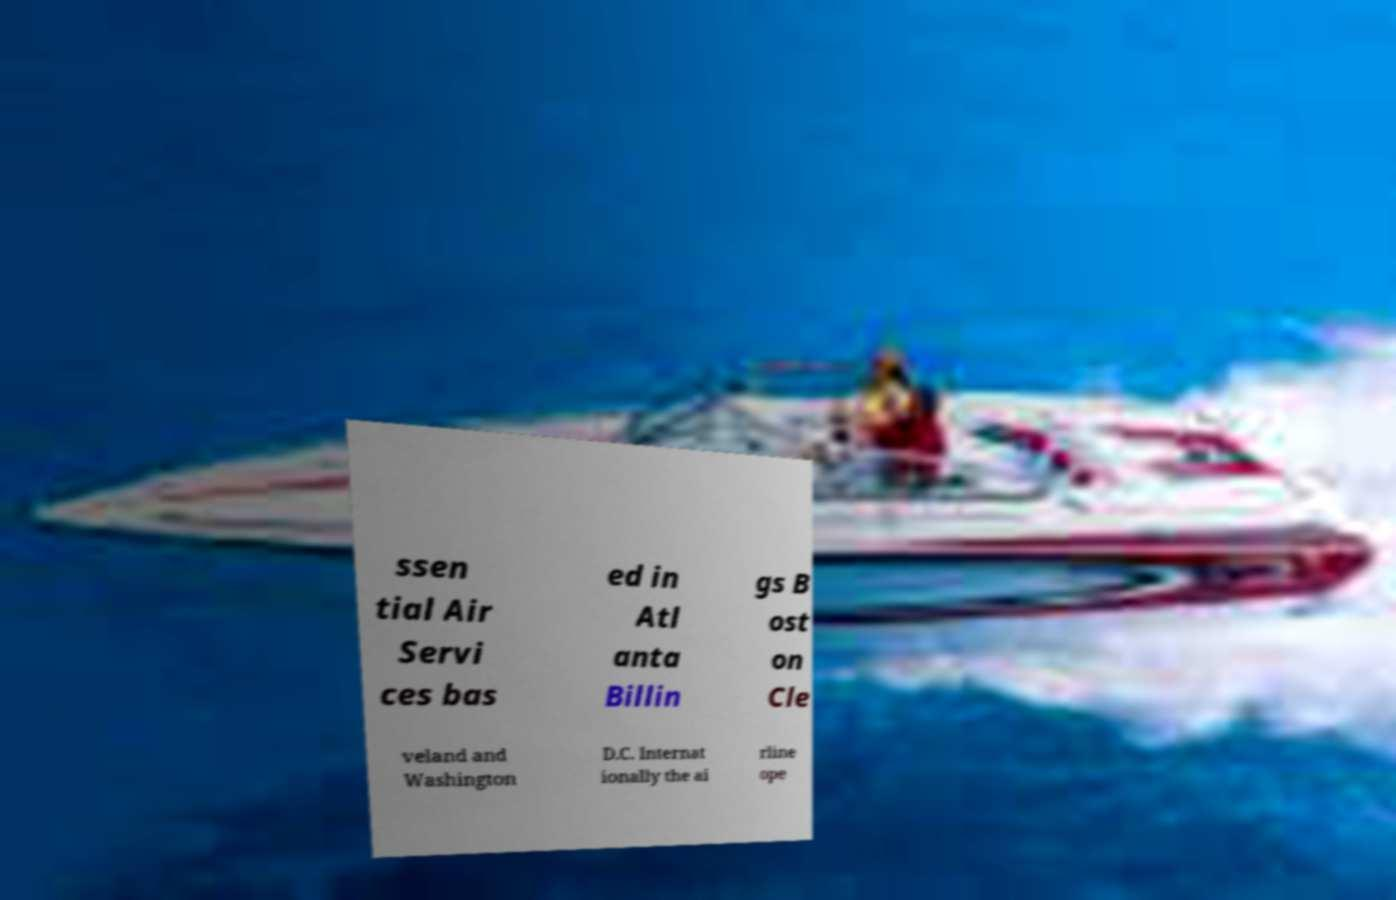Can you accurately transcribe the text from the provided image for me? ssen tial Air Servi ces bas ed in Atl anta Billin gs B ost on Cle veland and Washington D.C. Internat ionally the ai rline ope 